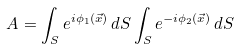<formula> <loc_0><loc_0><loc_500><loc_500>A = \int _ { S } e ^ { i \phi _ { 1 } ( \vec { x } ) } \, d S \int _ { S } e ^ { - i \phi _ { 2 } ( \vec { x } ) } \, d S</formula> 